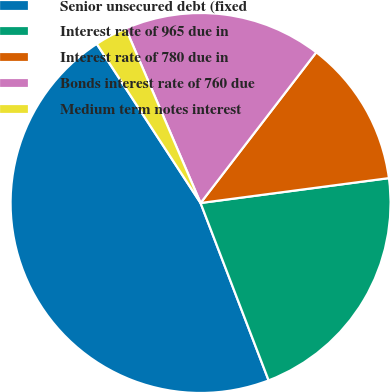Convert chart to OTSL. <chart><loc_0><loc_0><loc_500><loc_500><pie_chart><fcel>Senior unsecured debt (fixed<fcel>Interest rate of 965 due in<fcel>Interest rate of 780 due in<fcel>Bonds interest rate of 760 due<fcel>Medium term notes interest<nl><fcel>46.63%<fcel>21.26%<fcel>12.49%<fcel>16.87%<fcel>2.75%<nl></chart> 